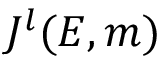<formula> <loc_0><loc_0><loc_500><loc_500>J ^ { l } ( E , m )</formula> 